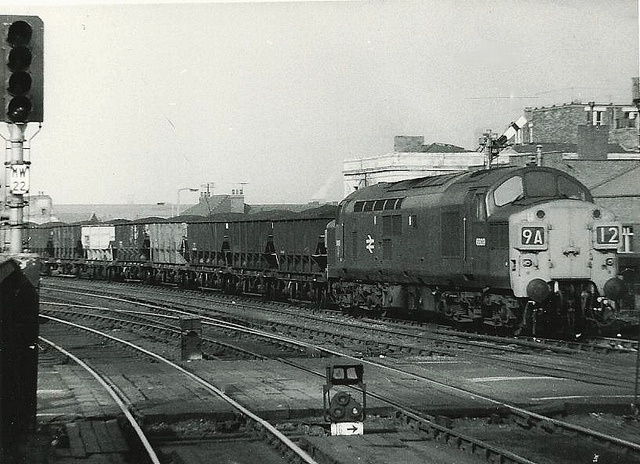Describe the objects in this image and their specific colors. I can see train in white, black, gray, and darkgray tones and traffic light in white, black, gray, and darkgray tones in this image. 